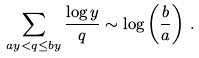Convert formula to latex. <formula><loc_0><loc_0><loc_500><loc_500>\sum _ { a y < q \leq b y } \frac { \log y } { q } \sim \log \left ( \frac { b } { a } \right ) \, .</formula> 